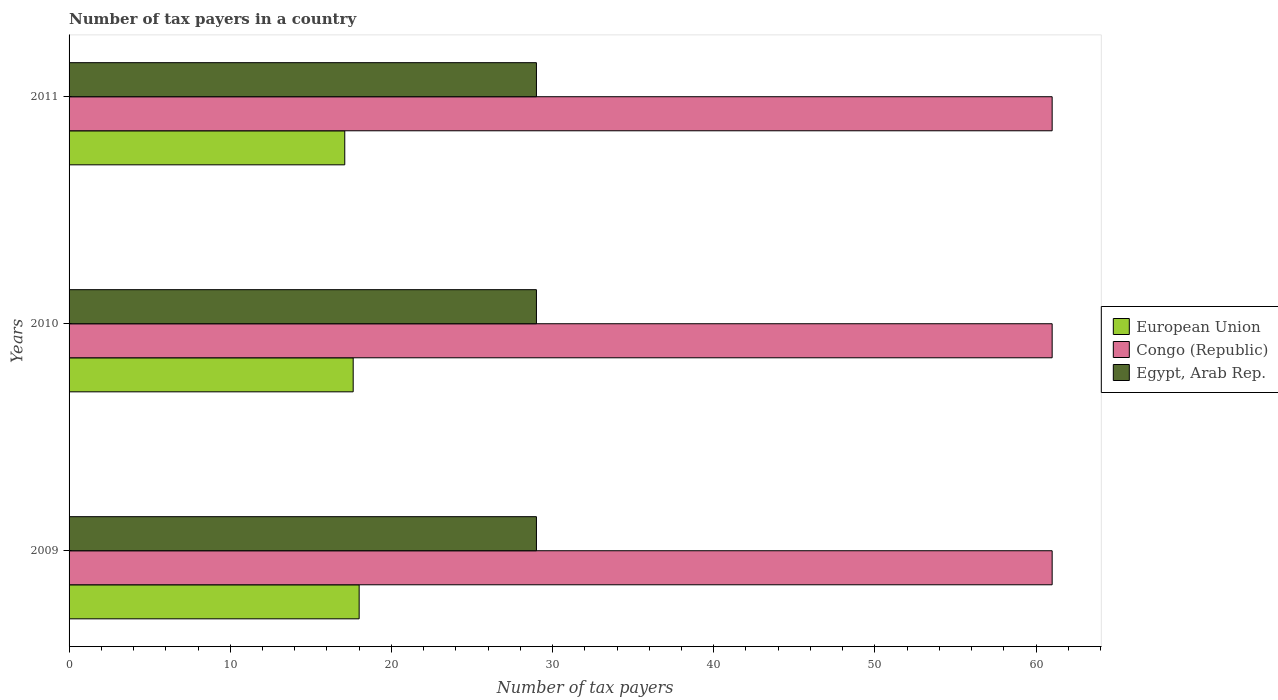How many different coloured bars are there?
Offer a very short reply. 3. What is the label of the 1st group of bars from the top?
Offer a terse response. 2011. In how many cases, is the number of bars for a given year not equal to the number of legend labels?
Give a very brief answer. 0. What is the number of tax payers in in Egypt, Arab Rep. in 2009?
Your response must be concise. 29. Across all years, what is the maximum number of tax payers in in Egypt, Arab Rep.?
Your response must be concise. 29. Across all years, what is the minimum number of tax payers in in Congo (Republic)?
Provide a short and direct response. 61. In which year was the number of tax payers in in Congo (Republic) maximum?
Ensure brevity in your answer.  2009. In which year was the number of tax payers in in Egypt, Arab Rep. minimum?
Provide a succinct answer. 2009. What is the total number of tax payers in in Egypt, Arab Rep. in the graph?
Offer a very short reply. 87. What is the difference between the number of tax payers in in Congo (Republic) in 2010 and the number of tax payers in in Egypt, Arab Rep. in 2009?
Your answer should be very brief. 32. What is the average number of tax payers in in Egypt, Arab Rep. per year?
Your answer should be very brief. 29. In the year 2011, what is the difference between the number of tax payers in in Egypt, Arab Rep. and number of tax payers in in Congo (Republic)?
Offer a very short reply. -32. In how many years, is the number of tax payers in in European Union greater than 10 ?
Provide a short and direct response. 3. What is the difference between the highest and the lowest number of tax payers in in European Union?
Provide a short and direct response. 0.89. In how many years, is the number of tax payers in in Congo (Republic) greater than the average number of tax payers in in Congo (Republic) taken over all years?
Your answer should be compact. 0. Is the sum of the number of tax payers in in Egypt, Arab Rep. in 2009 and 2010 greater than the maximum number of tax payers in in Congo (Republic) across all years?
Offer a very short reply. No. What does the 2nd bar from the bottom in 2010 represents?
Your answer should be very brief. Congo (Republic). How many bars are there?
Your answer should be compact. 9. What is the difference between two consecutive major ticks on the X-axis?
Ensure brevity in your answer.  10. Are the values on the major ticks of X-axis written in scientific E-notation?
Your answer should be very brief. No. Does the graph contain any zero values?
Offer a very short reply. No. Does the graph contain grids?
Provide a succinct answer. No. How many legend labels are there?
Offer a very short reply. 3. How are the legend labels stacked?
Offer a terse response. Vertical. What is the title of the graph?
Ensure brevity in your answer.  Number of tax payers in a country. Does "Turkey" appear as one of the legend labels in the graph?
Your answer should be very brief. No. What is the label or title of the X-axis?
Ensure brevity in your answer.  Number of tax payers. What is the label or title of the Y-axis?
Ensure brevity in your answer.  Years. What is the Number of tax payers in European Union in 2009?
Provide a succinct answer. 18. What is the Number of tax payers of Congo (Republic) in 2009?
Make the answer very short. 61. What is the Number of tax payers of European Union in 2010?
Provide a succinct answer. 17.63. What is the Number of tax payers of Congo (Republic) in 2010?
Ensure brevity in your answer.  61. What is the Number of tax payers of European Union in 2011?
Ensure brevity in your answer.  17.11. What is the Number of tax payers in Congo (Republic) in 2011?
Offer a terse response. 61. What is the Number of tax payers in Egypt, Arab Rep. in 2011?
Provide a succinct answer. 29. Across all years, what is the maximum Number of tax payers of Congo (Republic)?
Your response must be concise. 61. Across all years, what is the minimum Number of tax payers in European Union?
Give a very brief answer. 17.11. What is the total Number of tax payers in European Union in the graph?
Ensure brevity in your answer.  52.74. What is the total Number of tax payers of Congo (Republic) in the graph?
Provide a succinct answer. 183. What is the difference between the Number of tax payers in European Union in 2009 and that in 2010?
Your answer should be compact. 0.37. What is the difference between the Number of tax payers in Egypt, Arab Rep. in 2009 and that in 2010?
Provide a succinct answer. 0. What is the difference between the Number of tax payers of European Union in 2009 and that in 2011?
Your response must be concise. 0.89. What is the difference between the Number of tax payers of European Union in 2010 and that in 2011?
Give a very brief answer. 0.52. What is the difference between the Number of tax payers of Congo (Republic) in 2010 and that in 2011?
Make the answer very short. 0. What is the difference between the Number of tax payers of Egypt, Arab Rep. in 2010 and that in 2011?
Give a very brief answer. 0. What is the difference between the Number of tax payers in European Union in 2009 and the Number of tax payers in Congo (Republic) in 2010?
Give a very brief answer. -43. What is the difference between the Number of tax payers in Congo (Republic) in 2009 and the Number of tax payers in Egypt, Arab Rep. in 2010?
Your answer should be compact. 32. What is the difference between the Number of tax payers in European Union in 2009 and the Number of tax payers in Congo (Republic) in 2011?
Your response must be concise. -43. What is the difference between the Number of tax payers in Congo (Republic) in 2009 and the Number of tax payers in Egypt, Arab Rep. in 2011?
Offer a terse response. 32. What is the difference between the Number of tax payers in European Union in 2010 and the Number of tax payers in Congo (Republic) in 2011?
Make the answer very short. -43.37. What is the difference between the Number of tax payers in European Union in 2010 and the Number of tax payers in Egypt, Arab Rep. in 2011?
Provide a short and direct response. -11.37. What is the average Number of tax payers in European Union per year?
Your response must be concise. 17.58. What is the average Number of tax payers of Congo (Republic) per year?
Provide a short and direct response. 61. What is the average Number of tax payers of Egypt, Arab Rep. per year?
Provide a short and direct response. 29. In the year 2009, what is the difference between the Number of tax payers of European Union and Number of tax payers of Congo (Republic)?
Your response must be concise. -43. In the year 2010, what is the difference between the Number of tax payers of European Union and Number of tax payers of Congo (Republic)?
Ensure brevity in your answer.  -43.37. In the year 2010, what is the difference between the Number of tax payers in European Union and Number of tax payers in Egypt, Arab Rep.?
Keep it short and to the point. -11.37. In the year 2010, what is the difference between the Number of tax payers in Congo (Republic) and Number of tax payers in Egypt, Arab Rep.?
Your answer should be compact. 32. In the year 2011, what is the difference between the Number of tax payers in European Union and Number of tax payers in Congo (Republic)?
Offer a terse response. -43.89. In the year 2011, what is the difference between the Number of tax payers in European Union and Number of tax payers in Egypt, Arab Rep.?
Provide a succinct answer. -11.89. In the year 2011, what is the difference between the Number of tax payers in Congo (Republic) and Number of tax payers in Egypt, Arab Rep.?
Your response must be concise. 32. What is the ratio of the Number of tax payers of European Union in 2009 to that in 2011?
Give a very brief answer. 1.05. What is the ratio of the Number of tax payers in Egypt, Arab Rep. in 2009 to that in 2011?
Keep it short and to the point. 1. What is the ratio of the Number of tax payers in European Union in 2010 to that in 2011?
Your answer should be compact. 1.03. What is the difference between the highest and the second highest Number of tax payers of European Union?
Provide a short and direct response. 0.37. What is the difference between the highest and the second highest Number of tax payers in Egypt, Arab Rep.?
Offer a very short reply. 0. What is the difference between the highest and the lowest Number of tax payers in European Union?
Your answer should be compact. 0.89. 